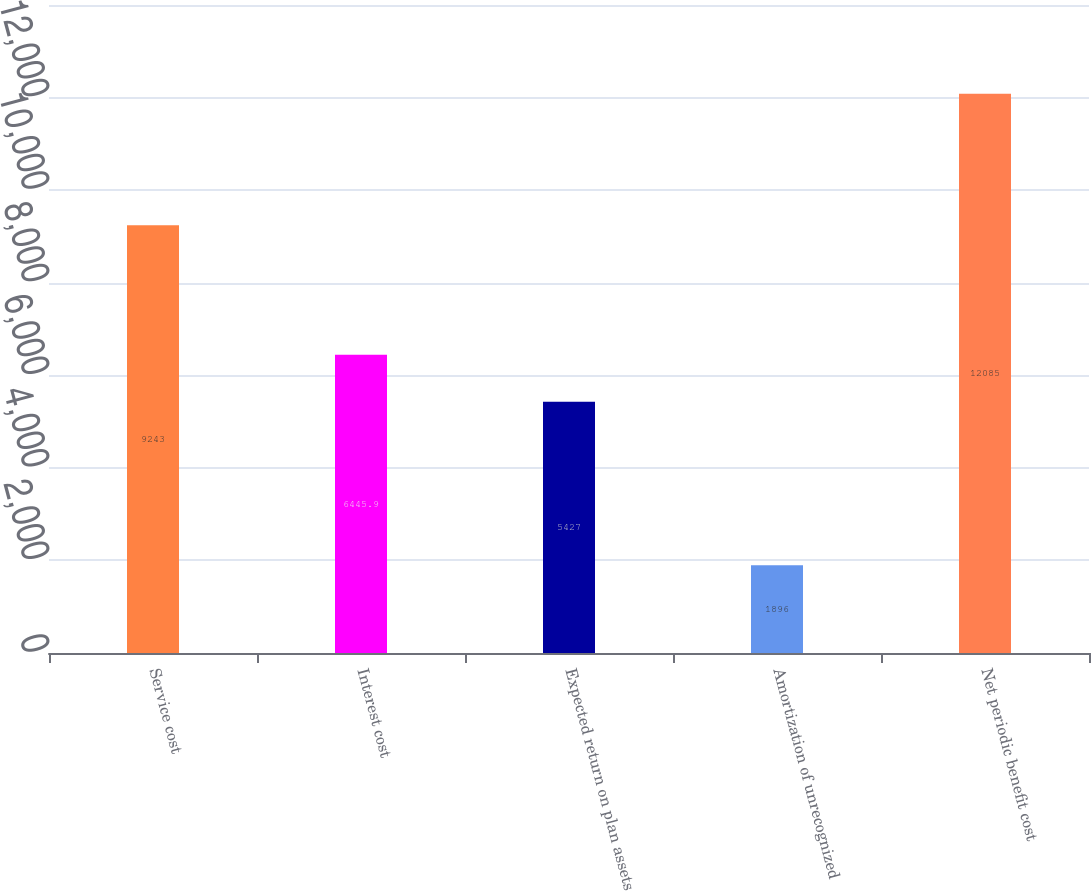<chart> <loc_0><loc_0><loc_500><loc_500><bar_chart><fcel>Service cost<fcel>Interest cost<fcel>Expected return on plan assets<fcel>Amortization of unrecognized<fcel>Net periodic benefit cost<nl><fcel>9243<fcel>6445.9<fcel>5427<fcel>1896<fcel>12085<nl></chart> 